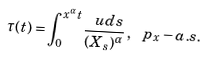Convert formula to latex. <formula><loc_0><loc_0><loc_500><loc_500>\tau ( t ) = \int _ { 0 } ^ { x ^ { \alpha } t } \frac { \ u d s } { ( X _ { s } ) ^ { \alpha } } \, , \, \ p _ { x } - a . s .</formula> 